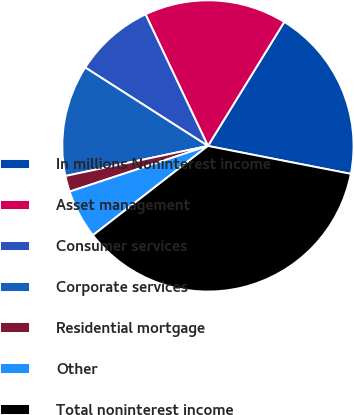<chart> <loc_0><loc_0><loc_500><loc_500><pie_chart><fcel>In millions Noninterest income<fcel>Asset management<fcel>Consumer services<fcel>Corporate services<fcel>Residential mortgage<fcel>Other<fcel>Total noninterest income<nl><fcel>19.29%<fcel>15.83%<fcel>8.9%<fcel>12.36%<fcel>1.77%<fcel>5.43%<fcel>36.42%<nl></chart> 